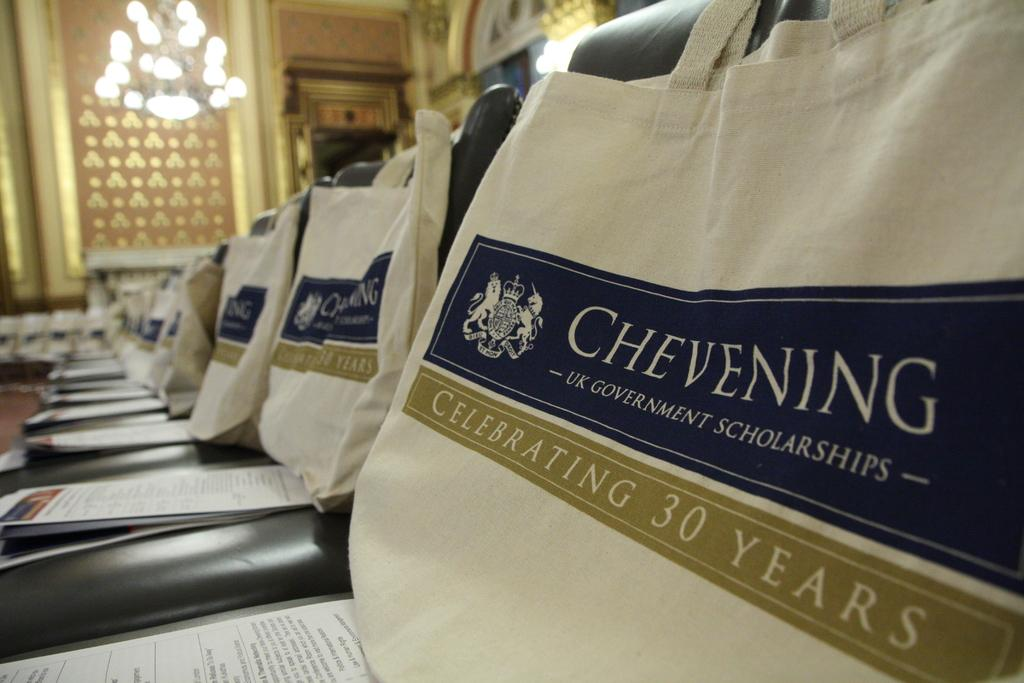<image>
Render a clear and concise summary of the photo. Several chairs which are decorated for a Chevening event and they are celebrating 30 years. 